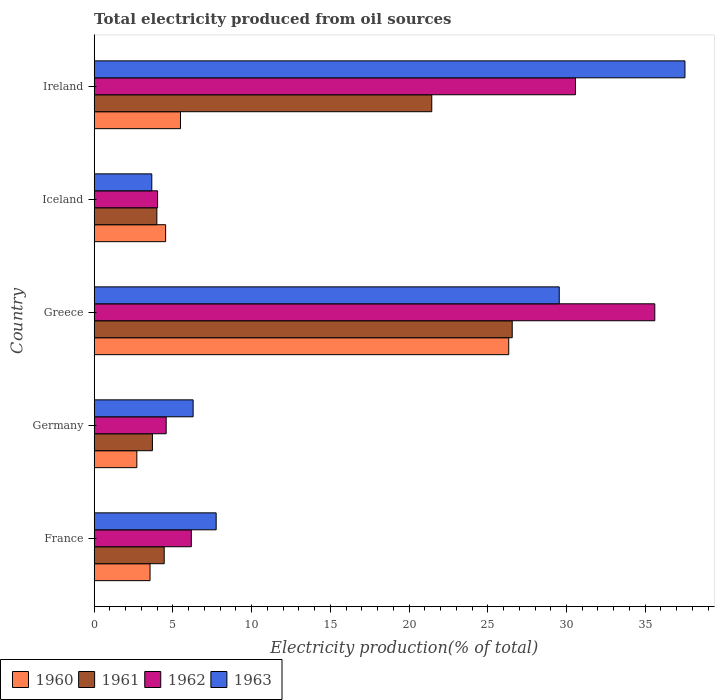How many different coloured bars are there?
Offer a very short reply. 4. Are the number of bars on each tick of the Y-axis equal?
Ensure brevity in your answer.  Yes. How many bars are there on the 5th tick from the bottom?
Your answer should be compact. 4. What is the label of the 1st group of bars from the top?
Your answer should be very brief. Ireland. What is the total electricity produced in 1961 in Germany?
Your answer should be very brief. 3.7. Across all countries, what is the maximum total electricity produced in 1963?
Give a very brief answer. 37.53. Across all countries, what is the minimum total electricity produced in 1960?
Offer a terse response. 2.71. In which country was the total electricity produced in 1961 maximum?
Offer a terse response. Greece. What is the total total electricity produced in 1961 in the graph?
Your response must be concise. 60.12. What is the difference between the total electricity produced in 1963 in Greece and that in Ireland?
Your answer should be very brief. -7.99. What is the difference between the total electricity produced in 1960 in Ireland and the total electricity produced in 1961 in Greece?
Offer a very short reply. -21.07. What is the average total electricity produced in 1962 per country?
Make the answer very short. 16.19. What is the difference between the total electricity produced in 1961 and total electricity produced in 1962 in Iceland?
Offer a very short reply. -0.05. In how many countries, is the total electricity produced in 1963 greater than 9 %?
Your answer should be compact. 2. What is the ratio of the total electricity produced in 1963 in Germany to that in Greece?
Your response must be concise. 0.21. Is the total electricity produced in 1962 in France less than that in Ireland?
Make the answer very short. Yes. Is the difference between the total electricity produced in 1961 in Iceland and Ireland greater than the difference between the total electricity produced in 1962 in Iceland and Ireland?
Ensure brevity in your answer.  Yes. What is the difference between the highest and the second highest total electricity produced in 1963?
Ensure brevity in your answer.  7.99. What is the difference between the highest and the lowest total electricity produced in 1961?
Provide a succinct answer. 22.86. In how many countries, is the total electricity produced in 1961 greater than the average total electricity produced in 1961 taken over all countries?
Your answer should be very brief. 2. Is it the case that in every country, the sum of the total electricity produced in 1961 and total electricity produced in 1962 is greater than the sum of total electricity produced in 1963 and total electricity produced in 1960?
Keep it short and to the point. No. Are all the bars in the graph horizontal?
Provide a succinct answer. Yes. How many countries are there in the graph?
Your answer should be very brief. 5. Are the values on the major ticks of X-axis written in scientific E-notation?
Make the answer very short. No. How are the legend labels stacked?
Provide a succinct answer. Horizontal. What is the title of the graph?
Your answer should be very brief. Total electricity produced from oil sources. What is the Electricity production(% of total) in 1960 in France?
Offer a terse response. 3.55. What is the Electricity production(% of total) of 1961 in France?
Give a very brief answer. 4.45. What is the Electricity production(% of total) in 1962 in France?
Your answer should be compact. 6.17. What is the Electricity production(% of total) of 1963 in France?
Give a very brief answer. 7.75. What is the Electricity production(% of total) of 1960 in Germany?
Your answer should be compact. 2.71. What is the Electricity production(% of total) of 1961 in Germany?
Keep it short and to the point. 3.7. What is the Electricity production(% of total) of 1962 in Germany?
Offer a terse response. 4.57. What is the Electricity production(% of total) in 1963 in Germany?
Your answer should be very brief. 6.28. What is the Electricity production(% of total) of 1960 in Greece?
Provide a succinct answer. 26.33. What is the Electricity production(% of total) in 1961 in Greece?
Keep it short and to the point. 26.55. What is the Electricity production(% of total) of 1962 in Greece?
Your response must be concise. 35.61. What is the Electricity production(% of total) in 1963 in Greece?
Your response must be concise. 29.54. What is the Electricity production(% of total) in 1960 in Iceland?
Offer a very short reply. 4.54. What is the Electricity production(% of total) of 1961 in Iceland?
Keep it short and to the point. 3.98. What is the Electricity production(% of total) of 1962 in Iceland?
Keep it short and to the point. 4.03. What is the Electricity production(% of total) in 1963 in Iceland?
Your answer should be compact. 3.66. What is the Electricity production(% of total) of 1960 in Ireland?
Ensure brevity in your answer.  5.48. What is the Electricity production(% of total) in 1961 in Ireland?
Make the answer very short. 21.44. What is the Electricity production(% of total) of 1962 in Ireland?
Keep it short and to the point. 30.57. What is the Electricity production(% of total) of 1963 in Ireland?
Give a very brief answer. 37.53. Across all countries, what is the maximum Electricity production(% of total) of 1960?
Make the answer very short. 26.33. Across all countries, what is the maximum Electricity production(% of total) of 1961?
Give a very brief answer. 26.55. Across all countries, what is the maximum Electricity production(% of total) of 1962?
Offer a very short reply. 35.61. Across all countries, what is the maximum Electricity production(% of total) in 1963?
Make the answer very short. 37.53. Across all countries, what is the minimum Electricity production(% of total) in 1960?
Your answer should be very brief. 2.71. Across all countries, what is the minimum Electricity production(% of total) of 1961?
Offer a very short reply. 3.7. Across all countries, what is the minimum Electricity production(% of total) of 1962?
Ensure brevity in your answer.  4.03. Across all countries, what is the minimum Electricity production(% of total) in 1963?
Offer a terse response. 3.66. What is the total Electricity production(% of total) of 1960 in the graph?
Make the answer very short. 42.61. What is the total Electricity production(% of total) in 1961 in the graph?
Your response must be concise. 60.12. What is the total Electricity production(% of total) in 1962 in the graph?
Offer a terse response. 80.95. What is the total Electricity production(% of total) in 1963 in the graph?
Your answer should be compact. 84.76. What is the difference between the Electricity production(% of total) in 1960 in France and that in Germany?
Ensure brevity in your answer.  0.84. What is the difference between the Electricity production(% of total) of 1961 in France and that in Germany?
Your answer should be very brief. 0.75. What is the difference between the Electricity production(% of total) of 1962 in France and that in Germany?
Offer a very short reply. 1.6. What is the difference between the Electricity production(% of total) in 1963 in France and that in Germany?
Your answer should be compact. 1.46. What is the difference between the Electricity production(% of total) of 1960 in France and that in Greece?
Your answer should be very brief. -22.78. What is the difference between the Electricity production(% of total) of 1961 in France and that in Greece?
Keep it short and to the point. -22.11. What is the difference between the Electricity production(% of total) in 1962 in France and that in Greece?
Offer a terse response. -29.44. What is the difference between the Electricity production(% of total) of 1963 in France and that in Greece?
Your answer should be compact. -21.79. What is the difference between the Electricity production(% of total) of 1960 in France and that in Iceland?
Your answer should be very brief. -0.99. What is the difference between the Electricity production(% of total) of 1961 in France and that in Iceland?
Offer a terse response. 0.47. What is the difference between the Electricity production(% of total) of 1962 in France and that in Iceland?
Your response must be concise. 2.14. What is the difference between the Electricity production(% of total) in 1963 in France and that in Iceland?
Provide a succinct answer. 4.09. What is the difference between the Electricity production(% of total) in 1960 in France and that in Ireland?
Your answer should be very brief. -1.93. What is the difference between the Electricity production(% of total) of 1961 in France and that in Ireland?
Your answer should be very brief. -17. What is the difference between the Electricity production(% of total) in 1962 in France and that in Ireland?
Your answer should be compact. -24.4. What is the difference between the Electricity production(% of total) in 1963 in France and that in Ireland?
Offer a terse response. -29.78. What is the difference between the Electricity production(% of total) of 1960 in Germany and that in Greece?
Make the answer very short. -23.62. What is the difference between the Electricity production(% of total) in 1961 in Germany and that in Greece?
Offer a terse response. -22.86. What is the difference between the Electricity production(% of total) in 1962 in Germany and that in Greece?
Keep it short and to the point. -31.04. What is the difference between the Electricity production(% of total) of 1963 in Germany and that in Greece?
Your response must be concise. -23.26. What is the difference between the Electricity production(% of total) of 1960 in Germany and that in Iceland?
Offer a terse response. -1.83. What is the difference between the Electricity production(% of total) of 1961 in Germany and that in Iceland?
Make the answer very short. -0.28. What is the difference between the Electricity production(% of total) of 1962 in Germany and that in Iceland?
Your answer should be compact. 0.55. What is the difference between the Electricity production(% of total) in 1963 in Germany and that in Iceland?
Give a very brief answer. 2.63. What is the difference between the Electricity production(% of total) in 1960 in Germany and that in Ireland?
Offer a very short reply. -2.77. What is the difference between the Electricity production(% of total) of 1961 in Germany and that in Ireland?
Offer a terse response. -17.75. What is the difference between the Electricity production(% of total) in 1962 in Germany and that in Ireland?
Give a very brief answer. -26. What is the difference between the Electricity production(% of total) in 1963 in Germany and that in Ireland?
Offer a terse response. -31.24. What is the difference between the Electricity production(% of total) of 1960 in Greece and that in Iceland?
Your answer should be very brief. 21.79. What is the difference between the Electricity production(% of total) in 1961 in Greece and that in Iceland?
Your answer should be compact. 22.57. What is the difference between the Electricity production(% of total) of 1962 in Greece and that in Iceland?
Ensure brevity in your answer.  31.58. What is the difference between the Electricity production(% of total) of 1963 in Greece and that in Iceland?
Your response must be concise. 25.88. What is the difference between the Electricity production(% of total) in 1960 in Greece and that in Ireland?
Give a very brief answer. 20.85. What is the difference between the Electricity production(% of total) in 1961 in Greece and that in Ireland?
Ensure brevity in your answer.  5.11. What is the difference between the Electricity production(% of total) in 1962 in Greece and that in Ireland?
Offer a very short reply. 5.04. What is the difference between the Electricity production(% of total) of 1963 in Greece and that in Ireland?
Your answer should be very brief. -7.99. What is the difference between the Electricity production(% of total) in 1960 in Iceland and that in Ireland?
Provide a short and direct response. -0.94. What is the difference between the Electricity production(% of total) of 1961 in Iceland and that in Ireland?
Your answer should be compact. -17.46. What is the difference between the Electricity production(% of total) of 1962 in Iceland and that in Ireland?
Your answer should be very brief. -26.55. What is the difference between the Electricity production(% of total) of 1963 in Iceland and that in Ireland?
Make the answer very short. -33.87. What is the difference between the Electricity production(% of total) of 1960 in France and the Electricity production(% of total) of 1961 in Germany?
Offer a terse response. -0.15. What is the difference between the Electricity production(% of total) of 1960 in France and the Electricity production(% of total) of 1962 in Germany?
Offer a terse response. -1.02. What is the difference between the Electricity production(% of total) of 1960 in France and the Electricity production(% of total) of 1963 in Germany?
Make the answer very short. -2.74. What is the difference between the Electricity production(% of total) in 1961 in France and the Electricity production(% of total) in 1962 in Germany?
Your answer should be very brief. -0.13. What is the difference between the Electricity production(% of total) of 1961 in France and the Electricity production(% of total) of 1963 in Germany?
Make the answer very short. -1.84. What is the difference between the Electricity production(% of total) of 1962 in France and the Electricity production(% of total) of 1963 in Germany?
Make the answer very short. -0.11. What is the difference between the Electricity production(% of total) in 1960 in France and the Electricity production(% of total) in 1961 in Greece?
Your response must be concise. -23.01. What is the difference between the Electricity production(% of total) in 1960 in France and the Electricity production(% of total) in 1962 in Greece?
Make the answer very short. -32.06. What is the difference between the Electricity production(% of total) in 1960 in France and the Electricity production(% of total) in 1963 in Greece?
Make the answer very short. -25.99. What is the difference between the Electricity production(% of total) of 1961 in France and the Electricity production(% of total) of 1962 in Greece?
Provide a short and direct response. -31.16. What is the difference between the Electricity production(% of total) in 1961 in France and the Electricity production(% of total) in 1963 in Greece?
Provide a succinct answer. -25.09. What is the difference between the Electricity production(% of total) in 1962 in France and the Electricity production(% of total) in 1963 in Greece?
Your answer should be very brief. -23.37. What is the difference between the Electricity production(% of total) in 1960 in France and the Electricity production(% of total) in 1961 in Iceland?
Provide a short and direct response. -0.43. What is the difference between the Electricity production(% of total) of 1960 in France and the Electricity production(% of total) of 1962 in Iceland?
Ensure brevity in your answer.  -0.48. What is the difference between the Electricity production(% of total) in 1960 in France and the Electricity production(% of total) in 1963 in Iceland?
Your answer should be compact. -0.11. What is the difference between the Electricity production(% of total) in 1961 in France and the Electricity production(% of total) in 1962 in Iceland?
Make the answer very short. 0.42. What is the difference between the Electricity production(% of total) in 1961 in France and the Electricity production(% of total) in 1963 in Iceland?
Offer a very short reply. 0.79. What is the difference between the Electricity production(% of total) of 1962 in France and the Electricity production(% of total) of 1963 in Iceland?
Make the answer very short. 2.51. What is the difference between the Electricity production(% of total) of 1960 in France and the Electricity production(% of total) of 1961 in Ireland?
Keep it short and to the point. -17.9. What is the difference between the Electricity production(% of total) in 1960 in France and the Electricity production(% of total) in 1962 in Ireland?
Ensure brevity in your answer.  -27.02. What is the difference between the Electricity production(% of total) in 1960 in France and the Electricity production(% of total) in 1963 in Ireland?
Offer a very short reply. -33.98. What is the difference between the Electricity production(% of total) of 1961 in France and the Electricity production(% of total) of 1962 in Ireland?
Make the answer very short. -26.12. What is the difference between the Electricity production(% of total) in 1961 in France and the Electricity production(% of total) in 1963 in Ireland?
Your answer should be compact. -33.08. What is the difference between the Electricity production(% of total) of 1962 in France and the Electricity production(% of total) of 1963 in Ireland?
Your answer should be compact. -31.36. What is the difference between the Electricity production(% of total) in 1960 in Germany and the Electricity production(% of total) in 1961 in Greece?
Ensure brevity in your answer.  -23.85. What is the difference between the Electricity production(% of total) of 1960 in Germany and the Electricity production(% of total) of 1962 in Greece?
Offer a very short reply. -32.9. What is the difference between the Electricity production(% of total) of 1960 in Germany and the Electricity production(% of total) of 1963 in Greece?
Offer a terse response. -26.83. What is the difference between the Electricity production(% of total) in 1961 in Germany and the Electricity production(% of total) in 1962 in Greece?
Give a very brief answer. -31.91. What is the difference between the Electricity production(% of total) in 1961 in Germany and the Electricity production(% of total) in 1963 in Greece?
Your answer should be very brief. -25.84. What is the difference between the Electricity production(% of total) in 1962 in Germany and the Electricity production(% of total) in 1963 in Greece?
Offer a terse response. -24.97. What is the difference between the Electricity production(% of total) in 1960 in Germany and the Electricity production(% of total) in 1961 in Iceland?
Make the answer very short. -1.27. What is the difference between the Electricity production(% of total) in 1960 in Germany and the Electricity production(% of total) in 1962 in Iceland?
Offer a terse response. -1.32. What is the difference between the Electricity production(% of total) in 1960 in Germany and the Electricity production(% of total) in 1963 in Iceland?
Your response must be concise. -0.95. What is the difference between the Electricity production(% of total) in 1961 in Germany and the Electricity production(% of total) in 1962 in Iceland?
Offer a very short reply. -0.33. What is the difference between the Electricity production(% of total) in 1961 in Germany and the Electricity production(% of total) in 1963 in Iceland?
Give a very brief answer. 0.04. What is the difference between the Electricity production(% of total) of 1962 in Germany and the Electricity production(% of total) of 1963 in Iceland?
Your answer should be compact. 0.91. What is the difference between the Electricity production(% of total) of 1960 in Germany and the Electricity production(% of total) of 1961 in Ireland?
Offer a very short reply. -18.73. What is the difference between the Electricity production(% of total) of 1960 in Germany and the Electricity production(% of total) of 1962 in Ireland?
Ensure brevity in your answer.  -27.86. What is the difference between the Electricity production(% of total) in 1960 in Germany and the Electricity production(% of total) in 1963 in Ireland?
Give a very brief answer. -34.82. What is the difference between the Electricity production(% of total) in 1961 in Germany and the Electricity production(% of total) in 1962 in Ireland?
Offer a very short reply. -26.87. What is the difference between the Electricity production(% of total) in 1961 in Germany and the Electricity production(% of total) in 1963 in Ireland?
Your response must be concise. -33.83. What is the difference between the Electricity production(% of total) in 1962 in Germany and the Electricity production(% of total) in 1963 in Ireland?
Provide a short and direct response. -32.95. What is the difference between the Electricity production(% of total) in 1960 in Greece and the Electricity production(% of total) in 1961 in Iceland?
Provide a short and direct response. 22.35. What is the difference between the Electricity production(% of total) in 1960 in Greece and the Electricity production(% of total) in 1962 in Iceland?
Give a very brief answer. 22.31. What is the difference between the Electricity production(% of total) of 1960 in Greece and the Electricity production(% of total) of 1963 in Iceland?
Give a very brief answer. 22.67. What is the difference between the Electricity production(% of total) of 1961 in Greece and the Electricity production(% of total) of 1962 in Iceland?
Make the answer very short. 22.53. What is the difference between the Electricity production(% of total) in 1961 in Greece and the Electricity production(% of total) in 1963 in Iceland?
Provide a short and direct response. 22.9. What is the difference between the Electricity production(% of total) in 1962 in Greece and the Electricity production(% of total) in 1963 in Iceland?
Ensure brevity in your answer.  31.95. What is the difference between the Electricity production(% of total) in 1960 in Greece and the Electricity production(% of total) in 1961 in Ireland?
Make the answer very short. 4.89. What is the difference between the Electricity production(% of total) in 1960 in Greece and the Electricity production(% of total) in 1962 in Ireland?
Your response must be concise. -4.24. What is the difference between the Electricity production(% of total) of 1960 in Greece and the Electricity production(% of total) of 1963 in Ireland?
Give a very brief answer. -11.19. What is the difference between the Electricity production(% of total) in 1961 in Greece and the Electricity production(% of total) in 1962 in Ireland?
Give a very brief answer. -4.02. What is the difference between the Electricity production(% of total) of 1961 in Greece and the Electricity production(% of total) of 1963 in Ireland?
Your answer should be very brief. -10.97. What is the difference between the Electricity production(% of total) of 1962 in Greece and the Electricity production(% of total) of 1963 in Ireland?
Offer a very short reply. -1.92. What is the difference between the Electricity production(% of total) of 1960 in Iceland and the Electricity production(% of total) of 1961 in Ireland?
Your response must be concise. -16.91. What is the difference between the Electricity production(% of total) in 1960 in Iceland and the Electricity production(% of total) in 1962 in Ireland?
Offer a very short reply. -26.03. What is the difference between the Electricity production(% of total) in 1960 in Iceland and the Electricity production(% of total) in 1963 in Ireland?
Provide a short and direct response. -32.99. What is the difference between the Electricity production(% of total) in 1961 in Iceland and the Electricity production(% of total) in 1962 in Ireland?
Your response must be concise. -26.59. What is the difference between the Electricity production(% of total) of 1961 in Iceland and the Electricity production(% of total) of 1963 in Ireland?
Provide a succinct answer. -33.55. What is the difference between the Electricity production(% of total) of 1962 in Iceland and the Electricity production(% of total) of 1963 in Ireland?
Provide a succinct answer. -33.5. What is the average Electricity production(% of total) in 1960 per country?
Provide a short and direct response. 8.52. What is the average Electricity production(% of total) in 1961 per country?
Your response must be concise. 12.02. What is the average Electricity production(% of total) in 1962 per country?
Give a very brief answer. 16.19. What is the average Electricity production(% of total) of 1963 per country?
Make the answer very short. 16.95. What is the difference between the Electricity production(% of total) in 1960 and Electricity production(% of total) in 1961 in France?
Your answer should be very brief. -0.9. What is the difference between the Electricity production(% of total) in 1960 and Electricity production(% of total) in 1962 in France?
Provide a short and direct response. -2.62. What is the difference between the Electricity production(% of total) in 1960 and Electricity production(% of total) in 1963 in France?
Offer a very short reply. -4.2. What is the difference between the Electricity production(% of total) in 1961 and Electricity production(% of total) in 1962 in France?
Your answer should be very brief. -1.72. What is the difference between the Electricity production(% of total) of 1961 and Electricity production(% of total) of 1963 in France?
Keep it short and to the point. -3.3. What is the difference between the Electricity production(% of total) of 1962 and Electricity production(% of total) of 1963 in France?
Ensure brevity in your answer.  -1.58. What is the difference between the Electricity production(% of total) in 1960 and Electricity production(% of total) in 1961 in Germany?
Provide a succinct answer. -0.99. What is the difference between the Electricity production(% of total) in 1960 and Electricity production(% of total) in 1962 in Germany?
Provide a succinct answer. -1.86. What is the difference between the Electricity production(% of total) in 1960 and Electricity production(% of total) in 1963 in Germany?
Keep it short and to the point. -3.58. What is the difference between the Electricity production(% of total) of 1961 and Electricity production(% of total) of 1962 in Germany?
Make the answer very short. -0.87. What is the difference between the Electricity production(% of total) of 1961 and Electricity production(% of total) of 1963 in Germany?
Your answer should be very brief. -2.59. What is the difference between the Electricity production(% of total) in 1962 and Electricity production(% of total) in 1963 in Germany?
Offer a very short reply. -1.71. What is the difference between the Electricity production(% of total) of 1960 and Electricity production(% of total) of 1961 in Greece?
Offer a very short reply. -0.22. What is the difference between the Electricity production(% of total) of 1960 and Electricity production(% of total) of 1962 in Greece?
Keep it short and to the point. -9.28. What is the difference between the Electricity production(% of total) of 1960 and Electricity production(% of total) of 1963 in Greece?
Make the answer very short. -3.21. What is the difference between the Electricity production(% of total) of 1961 and Electricity production(% of total) of 1962 in Greece?
Provide a succinct answer. -9.06. What is the difference between the Electricity production(% of total) of 1961 and Electricity production(% of total) of 1963 in Greece?
Offer a very short reply. -2.99. What is the difference between the Electricity production(% of total) in 1962 and Electricity production(% of total) in 1963 in Greece?
Provide a succinct answer. 6.07. What is the difference between the Electricity production(% of total) in 1960 and Electricity production(% of total) in 1961 in Iceland?
Your answer should be very brief. 0.56. What is the difference between the Electricity production(% of total) of 1960 and Electricity production(% of total) of 1962 in Iceland?
Ensure brevity in your answer.  0.51. What is the difference between the Electricity production(% of total) in 1960 and Electricity production(% of total) in 1963 in Iceland?
Give a very brief answer. 0.88. What is the difference between the Electricity production(% of total) in 1961 and Electricity production(% of total) in 1962 in Iceland?
Offer a very short reply. -0.05. What is the difference between the Electricity production(% of total) in 1961 and Electricity production(% of total) in 1963 in Iceland?
Provide a succinct answer. 0.32. What is the difference between the Electricity production(% of total) in 1962 and Electricity production(% of total) in 1963 in Iceland?
Make the answer very short. 0.37. What is the difference between the Electricity production(% of total) in 1960 and Electricity production(% of total) in 1961 in Ireland?
Offer a terse response. -15.96. What is the difference between the Electricity production(% of total) in 1960 and Electricity production(% of total) in 1962 in Ireland?
Ensure brevity in your answer.  -25.09. What is the difference between the Electricity production(% of total) in 1960 and Electricity production(% of total) in 1963 in Ireland?
Give a very brief answer. -32.04. What is the difference between the Electricity production(% of total) in 1961 and Electricity production(% of total) in 1962 in Ireland?
Your answer should be compact. -9.13. What is the difference between the Electricity production(% of total) in 1961 and Electricity production(% of total) in 1963 in Ireland?
Ensure brevity in your answer.  -16.08. What is the difference between the Electricity production(% of total) of 1962 and Electricity production(% of total) of 1963 in Ireland?
Make the answer very short. -6.95. What is the ratio of the Electricity production(% of total) in 1960 in France to that in Germany?
Keep it short and to the point. 1.31. What is the ratio of the Electricity production(% of total) of 1961 in France to that in Germany?
Give a very brief answer. 1.2. What is the ratio of the Electricity production(% of total) of 1962 in France to that in Germany?
Provide a succinct answer. 1.35. What is the ratio of the Electricity production(% of total) in 1963 in France to that in Germany?
Ensure brevity in your answer.  1.23. What is the ratio of the Electricity production(% of total) of 1960 in France to that in Greece?
Provide a succinct answer. 0.13. What is the ratio of the Electricity production(% of total) in 1961 in France to that in Greece?
Offer a terse response. 0.17. What is the ratio of the Electricity production(% of total) in 1962 in France to that in Greece?
Offer a terse response. 0.17. What is the ratio of the Electricity production(% of total) in 1963 in France to that in Greece?
Ensure brevity in your answer.  0.26. What is the ratio of the Electricity production(% of total) of 1960 in France to that in Iceland?
Provide a short and direct response. 0.78. What is the ratio of the Electricity production(% of total) of 1961 in France to that in Iceland?
Your answer should be compact. 1.12. What is the ratio of the Electricity production(% of total) of 1962 in France to that in Iceland?
Your answer should be very brief. 1.53. What is the ratio of the Electricity production(% of total) in 1963 in France to that in Iceland?
Your answer should be very brief. 2.12. What is the ratio of the Electricity production(% of total) in 1960 in France to that in Ireland?
Offer a terse response. 0.65. What is the ratio of the Electricity production(% of total) of 1961 in France to that in Ireland?
Provide a short and direct response. 0.21. What is the ratio of the Electricity production(% of total) in 1962 in France to that in Ireland?
Provide a succinct answer. 0.2. What is the ratio of the Electricity production(% of total) of 1963 in France to that in Ireland?
Your answer should be compact. 0.21. What is the ratio of the Electricity production(% of total) of 1960 in Germany to that in Greece?
Make the answer very short. 0.1. What is the ratio of the Electricity production(% of total) of 1961 in Germany to that in Greece?
Your answer should be compact. 0.14. What is the ratio of the Electricity production(% of total) in 1962 in Germany to that in Greece?
Your response must be concise. 0.13. What is the ratio of the Electricity production(% of total) of 1963 in Germany to that in Greece?
Ensure brevity in your answer.  0.21. What is the ratio of the Electricity production(% of total) of 1960 in Germany to that in Iceland?
Your answer should be very brief. 0.6. What is the ratio of the Electricity production(% of total) in 1961 in Germany to that in Iceland?
Keep it short and to the point. 0.93. What is the ratio of the Electricity production(% of total) in 1962 in Germany to that in Iceland?
Ensure brevity in your answer.  1.14. What is the ratio of the Electricity production(% of total) of 1963 in Germany to that in Iceland?
Make the answer very short. 1.72. What is the ratio of the Electricity production(% of total) in 1960 in Germany to that in Ireland?
Offer a very short reply. 0.49. What is the ratio of the Electricity production(% of total) of 1961 in Germany to that in Ireland?
Keep it short and to the point. 0.17. What is the ratio of the Electricity production(% of total) of 1962 in Germany to that in Ireland?
Offer a very short reply. 0.15. What is the ratio of the Electricity production(% of total) of 1963 in Germany to that in Ireland?
Your answer should be compact. 0.17. What is the ratio of the Electricity production(% of total) of 1960 in Greece to that in Iceland?
Keep it short and to the point. 5.8. What is the ratio of the Electricity production(% of total) of 1961 in Greece to that in Iceland?
Make the answer very short. 6.67. What is the ratio of the Electricity production(% of total) in 1962 in Greece to that in Iceland?
Offer a very short reply. 8.85. What is the ratio of the Electricity production(% of total) of 1963 in Greece to that in Iceland?
Your response must be concise. 8.07. What is the ratio of the Electricity production(% of total) in 1960 in Greece to that in Ireland?
Make the answer very short. 4.8. What is the ratio of the Electricity production(% of total) in 1961 in Greece to that in Ireland?
Make the answer very short. 1.24. What is the ratio of the Electricity production(% of total) of 1962 in Greece to that in Ireland?
Your answer should be very brief. 1.16. What is the ratio of the Electricity production(% of total) of 1963 in Greece to that in Ireland?
Offer a very short reply. 0.79. What is the ratio of the Electricity production(% of total) in 1960 in Iceland to that in Ireland?
Your answer should be compact. 0.83. What is the ratio of the Electricity production(% of total) in 1961 in Iceland to that in Ireland?
Ensure brevity in your answer.  0.19. What is the ratio of the Electricity production(% of total) of 1962 in Iceland to that in Ireland?
Your answer should be very brief. 0.13. What is the ratio of the Electricity production(% of total) of 1963 in Iceland to that in Ireland?
Ensure brevity in your answer.  0.1. What is the difference between the highest and the second highest Electricity production(% of total) in 1960?
Ensure brevity in your answer.  20.85. What is the difference between the highest and the second highest Electricity production(% of total) of 1961?
Offer a terse response. 5.11. What is the difference between the highest and the second highest Electricity production(% of total) in 1962?
Provide a succinct answer. 5.04. What is the difference between the highest and the second highest Electricity production(% of total) in 1963?
Offer a very short reply. 7.99. What is the difference between the highest and the lowest Electricity production(% of total) in 1960?
Offer a very short reply. 23.62. What is the difference between the highest and the lowest Electricity production(% of total) in 1961?
Ensure brevity in your answer.  22.86. What is the difference between the highest and the lowest Electricity production(% of total) of 1962?
Provide a succinct answer. 31.58. What is the difference between the highest and the lowest Electricity production(% of total) in 1963?
Your answer should be compact. 33.87. 